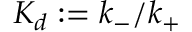Convert formula to latex. <formula><loc_0><loc_0><loc_500><loc_500>K _ { d } \colon = k _ { - } / k _ { + }</formula> 